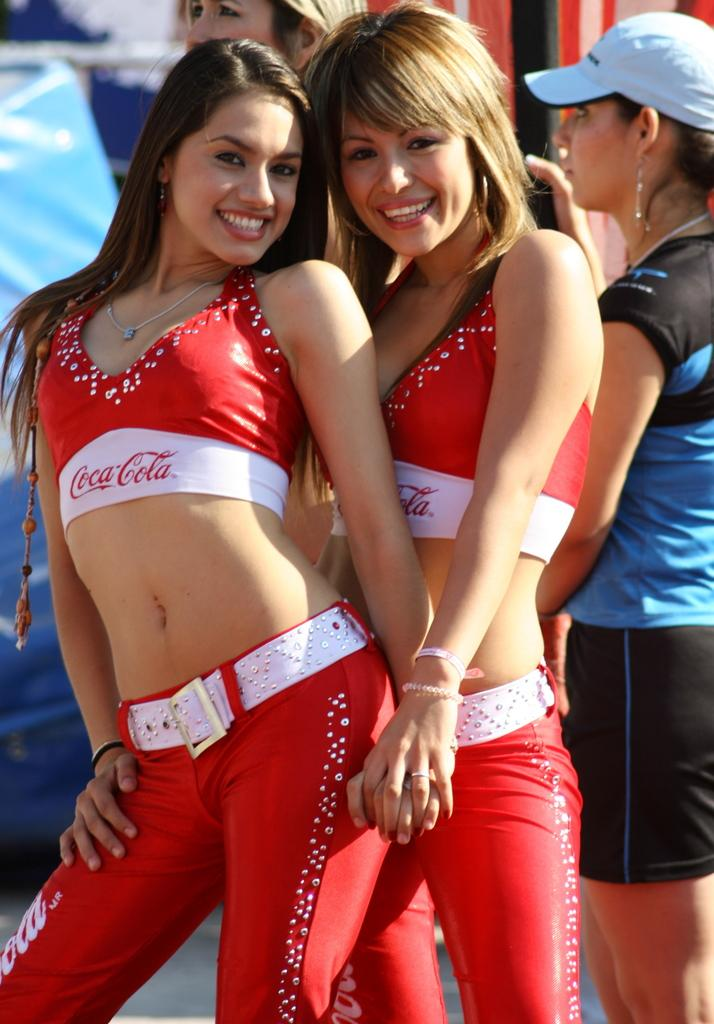Who is in the front of the image? There are women standing in the front of the image. What are the women doing in the image? The women are smiling. What can be seen in the background of the image? There are persons in the background of the image. What colors are present in the image? There are blue and red objects in the image. What type of insurance policy is being discussed by the women in the image? There is no indication in the image that the women are discussing any insurance policies. 